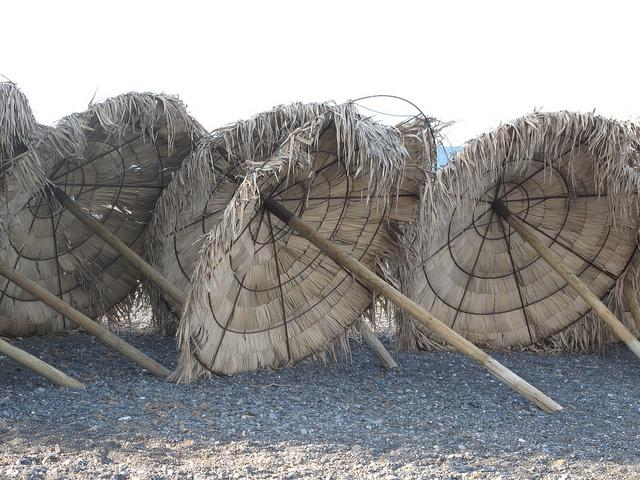What style of umbrella is seen here? straw 